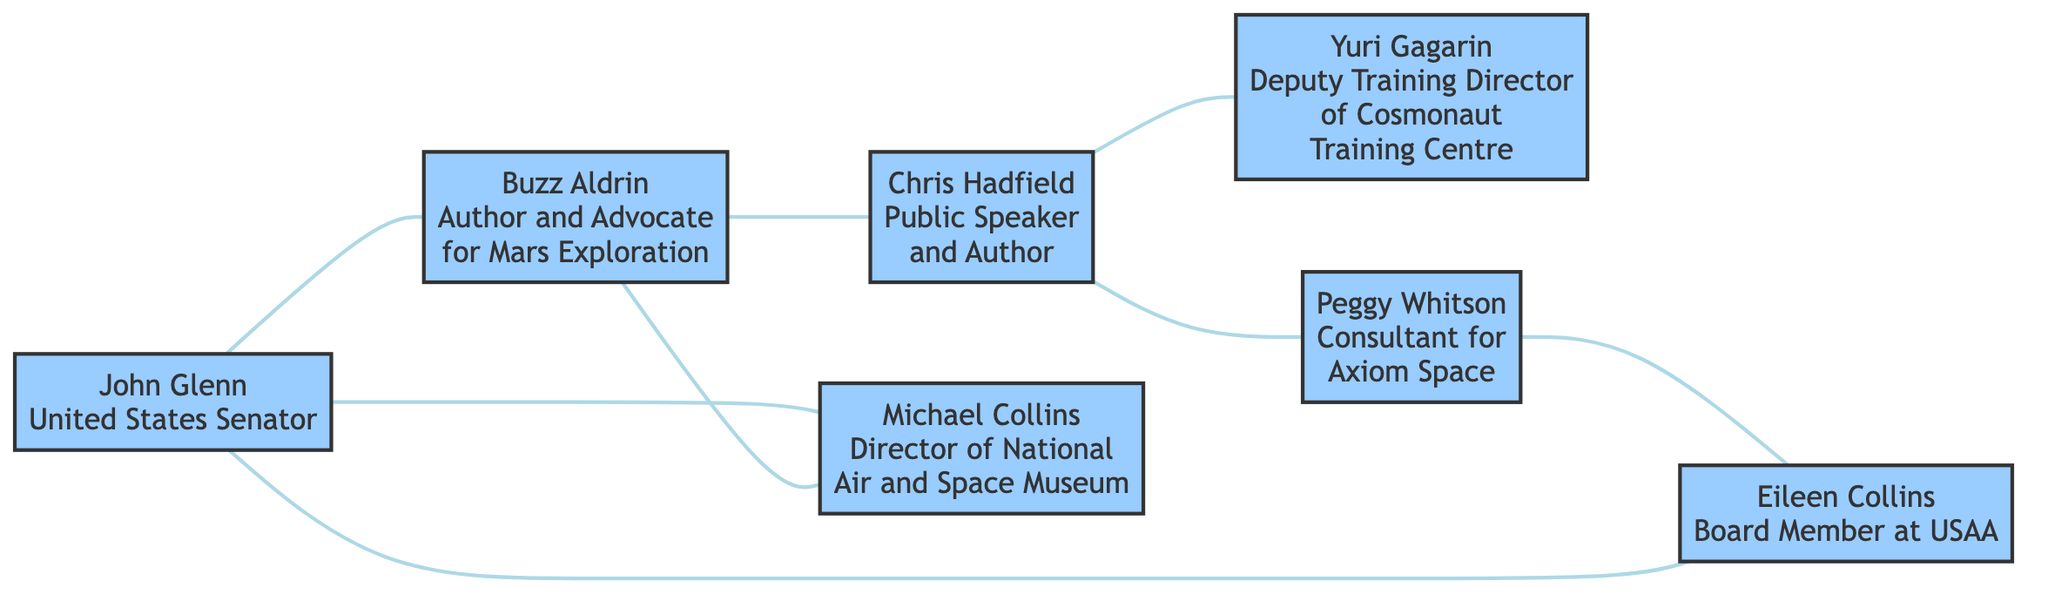What is the total number of nodes in the diagram? There are 7 unique nodes identified: John Glenn, Buzz Aldrin, Chris Hadfield, Yuri Gagarin, Peggy Whitson, Michael Collins, and Eileen Collins. Counting these gives a total of 7 nodes.
Answer: 7 Which two astronauts are connected by the relationship "Fellow Astronaut"? The relationship "Fellow Astronaut" exists between John Glenn and Buzz Aldrin, as well as John Glenn and Michael Collins. The question asks for two specific ones, so I provide John Glenn and Buzz Aldrin.
Answer: John Glenn, Buzz Aldrin How many edges connect the nodes in the diagram? The diagram lists 8 connections (edges) between various astronauts, each marked by relationships. Counting these gives a total of 8 edges.
Answer: 8 Who is connected to Chris Hadfield as an "ISS Commander"? Chris Hadfield is connected to Peggy Whitson as noted by the relationship "ISS Commanders". There is only one specific connection for this relationship in the diagram.
Answer: Peggy Whitson What is the common relationship between Buzz Aldrin and Chris Hadfield? The relationship shared between Buzz Aldrin and Chris Hadfield is labeled as "Space Advocates". This term indicates their mutual involvement in advocacy for space exploration.
Answer: Space Advocates Which retired astronaut has a career as a "Consultant for Axiom Space"? The node representing Peggy Whitson states her career as a "Consultant for Axiom Space". Therefore, she is the astronaut in that role as indicated in the diagram.
Answer: Peggy Whitson How many astronauts are connected directly to John Glenn? John Glenn is directly connected to three other astronauts: Buzz Aldrin, Michael Collins, and Eileen Collins, making three direct connections in total.
Answer: 3 Which two astronauts are connected through their shared status as "NASA Astronauts"? The connection of "NASA Astronauts" exists between Peggy Whitson and Eileen Collins in the diagram. Therefore, they are the two focused individuals with that specific relationship.
Answer: Peggy Whitson, Eileen Collins 